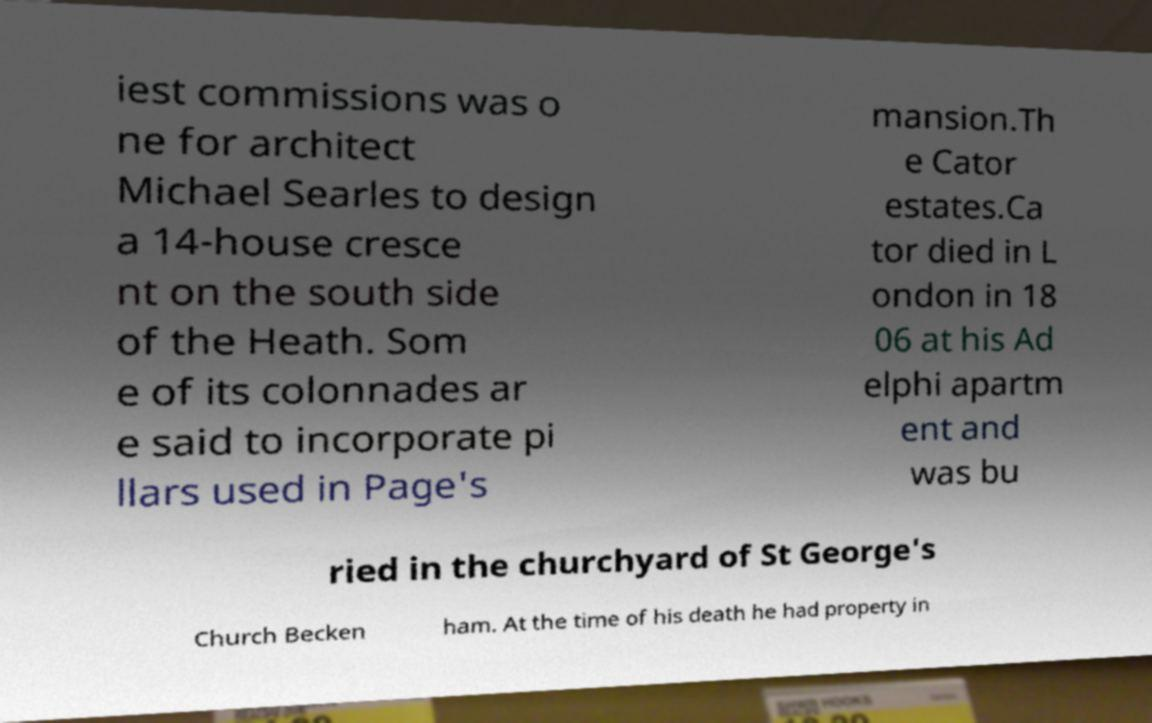Can you read and provide the text displayed in the image?This photo seems to have some interesting text. Can you extract and type it out for me? iest commissions was o ne for architect Michael Searles to design a 14-house cresce nt on the south side of the Heath. Som e of its colonnades ar e said to incorporate pi llars used in Page's mansion.Th e Cator estates.Ca tor died in L ondon in 18 06 at his Ad elphi apartm ent and was bu ried in the churchyard of St George's Church Becken ham. At the time of his death he had property in 